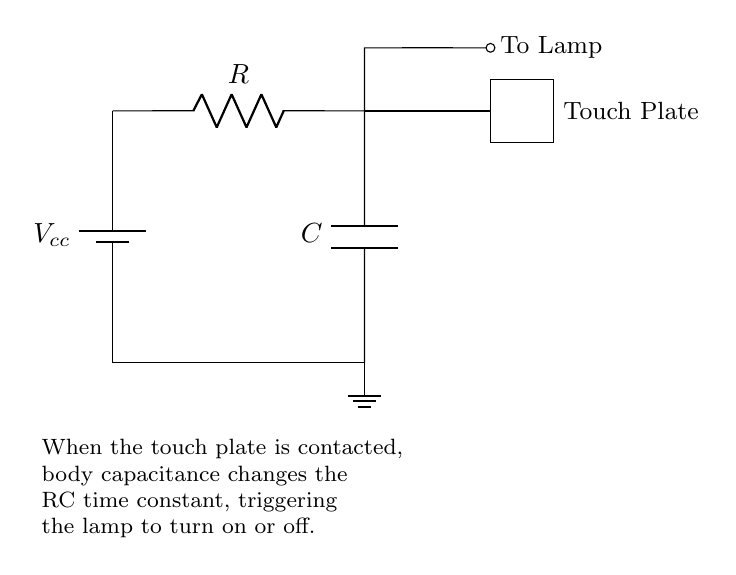What is the voltage source in the circuit? The voltage source is indicated by the battery symbol at the beginning of the circuit diagram labeled as \( V_{cc} \). This represents the supply voltage for the circuit.
Answer: \( V_{cc} \) What component allows the lamp to turn on or off? The touch plate acts as a switch that, when contacted, modifies the circuit by changing the capacitance, which in turn affects the behavior of the lamp.
Answer: Touch plate What is the role of the resistor in this circuit? The resistor \( R \) is crucial for limiting the current in the circuit and together with the capacitor affects the time constant, which determines how quickly the lamp responds to a touch.
Answer: Limit current What happens when the touch plate is contacted? Contacting the touch plate changes the body capacitance, affecting the RC time constant and potentially triggering the lamp to turn on or off depending on the existing state.
Answer: Triggers lamp What does \( C \) represent in the circuit? \( C \) represents the capacitor in the circuit, which stores electrical energy and is essential for creating the time delay that influences the lamp's operation upon touching the plate.
Answer: Capacitor How does body capacitance impact the circuit's function? Body capacitance momentarily affects the total capacitance in the circuit when the touch plate is contacted, altering the RC time constant and thus the operation of the lamp.
Answer: Alters time constant What type of circuit is represented here? The circuit is a simple resistor-capacitor (RC) circuit, commonly used for timing applications such as this touch-sensitive lamp.
Answer: RC circuit 